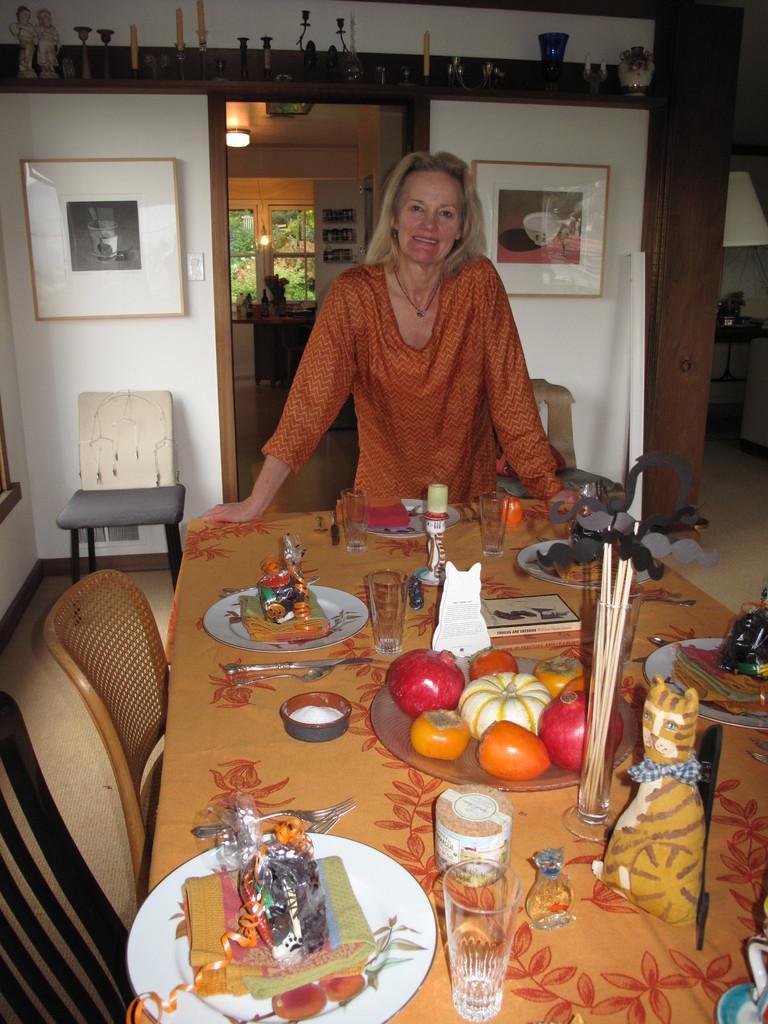In one or two sentences, can you explain what this image depicts? In this image we can see a woman standing near table. We can see plates, glasses and some things on the table. In the background we can see chairs, photo frames on wall and another room. 